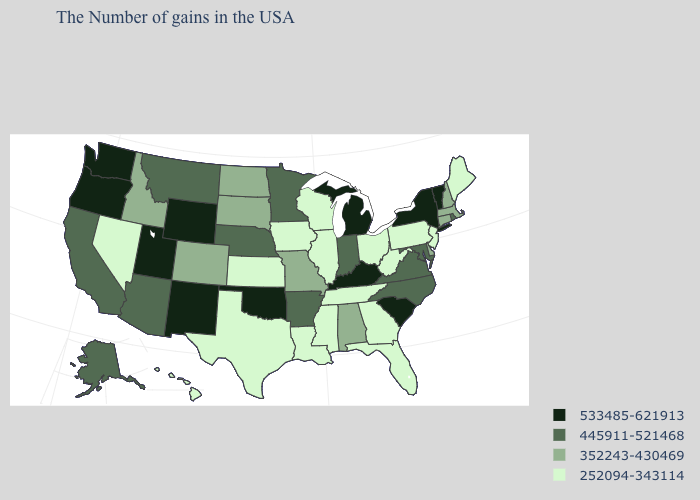Among the states that border Michigan , which have the lowest value?
Be succinct. Ohio, Wisconsin. Name the states that have a value in the range 252094-343114?
Quick response, please. Maine, New Jersey, Pennsylvania, West Virginia, Ohio, Florida, Georgia, Tennessee, Wisconsin, Illinois, Mississippi, Louisiana, Iowa, Kansas, Texas, Nevada, Hawaii. Which states have the highest value in the USA?
Keep it brief. Vermont, New York, South Carolina, Michigan, Kentucky, Oklahoma, Wyoming, New Mexico, Utah, Washington, Oregon. What is the lowest value in states that border Massachusetts?
Keep it brief. 352243-430469. How many symbols are there in the legend?
Give a very brief answer. 4. Name the states that have a value in the range 252094-343114?
Keep it brief. Maine, New Jersey, Pennsylvania, West Virginia, Ohio, Florida, Georgia, Tennessee, Wisconsin, Illinois, Mississippi, Louisiana, Iowa, Kansas, Texas, Nevada, Hawaii. Name the states that have a value in the range 445911-521468?
Concise answer only. Rhode Island, Maryland, Virginia, North Carolina, Indiana, Arkansas, Minnesota, Nebraska, Montana, Arizona, California, Alaska. Name the states that have a value in the range 445911-521468?
Keep it brief. Rhode Island, Maryland, Virginia, North Carolina, Indiana, Arkansas, Minnesota, Nebraska, Montana, Arizona, California, Alaska. What is the highest value in the USA?
Short answer required. 533485-621913. Does Michigan have the lowest value in the MidWest?
Concise answer only. No. Name the states that have a value in the range 533485-621913?
Short answer required. Vermont, New York, South Carolina, Michigan, Kentucky, Oklahoma, Wyoming, New Mexico, Utah, Washington, Oregon. What is the lowest value in the USA?
Write a very short answer. 252094-343114. Name the states that have a value in the range 352243-430469?
Concise answer only. Massachusetts, New Hampshire, Connecticut, Delaware, Alabama, Missouri, South Dakota, North Dakota, Colorado, Idaho. Does Idaho have a higher value than Illinois?
Write a very short answer. Yes. Among the states that border Wyoming , which have the highest value?
Concise answer only. Utah. 